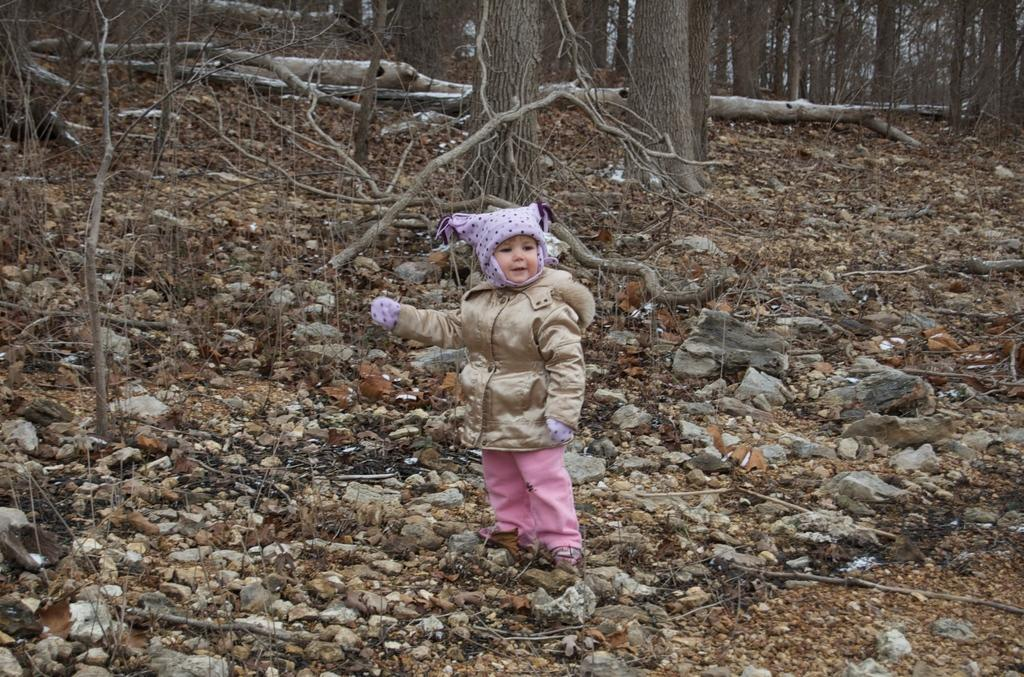What is the main subject of the image? There is a kid in the image. What can be seen in the background of the image? There are stones and trees in the background of the image. What type of collar can be seen on the kid's trousers in the image? There is no mention of trousers or collars in the image, as it only features a kid and the background with stones and trees. 